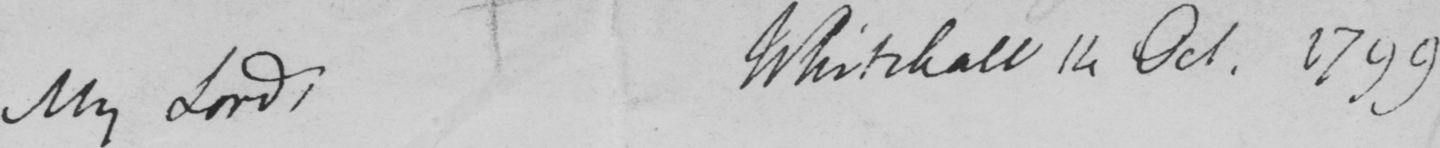Please transcribe the handwritten text in this image. My Lords, Whitehall 14 Oct. 1799. 